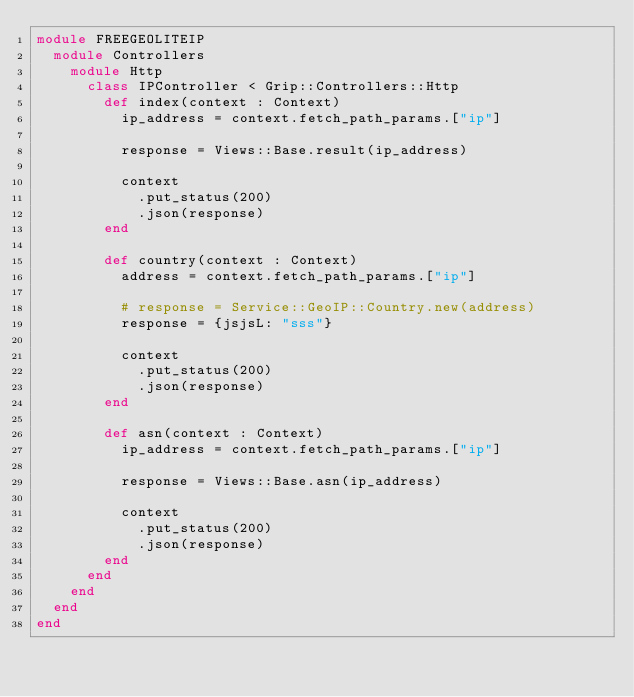<code> <loc_0><loc_0><loc_500><loc_500><_Crystal_>module FREEGEOLITEIP
  module Controllers
    module Http
      class IPController < Grip::Controllers::Http
        def index(context : Context)
          ip_address = context.fetch_path_params.["ip"]

          response = Views::Base.result(ip_address)

          context
            .put_status(200)
            .json(response)
        end

        def country(context : Context)
          address = context.fetch_path_params.["ip"]
          
          # response = Service::GeoIP::Country.new(address)
          response = {jsjsL: "sss"}

          context
            .put_status(200)
            .json(response)
        end

        def asn(context : Context)
          ip_address = context.fetch_path_params.["ip"]

          response = Views::Base.asn(ip_address)

          context
            .put_status(200)
            .json(response)
        end
      end
    end
  end
end</code> 